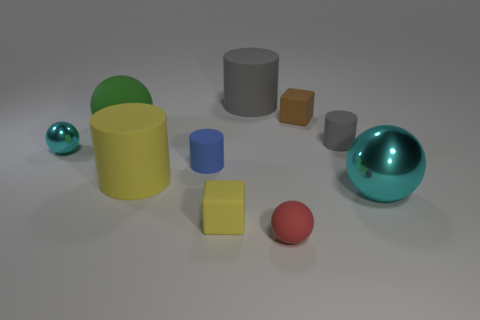Are there an equal number of green balls in front of the tiny blue object and red matte objects?
Provide a succinct answer. No. Do the blue matte cylinder and the green rubber object have the same size?
Your response must be concise. No. How many rubber objects are either tiny cyan objects or green cylinders?
Give a very brief answer. 0. There is a brown object that is the same size as the red thing; what material is it?
Give a very brief answer. Rubber. What number of other objects are the same material as the red thing?
Your answer should be very brief. 7. Is the number of small cyan shiny balls in front of the small rubber sphere less than the number of blue matte blocks?
Provide a succinct answer. No. Do the small yellow object and the big yellow object have the same shape?
Your answer should be very brief. No. What size is the cube that is on the left side of the small ball on the right side of the cube in front of the tiny gray rubber object?
Provide a short and direct response. Small. What is the material of the other large object that is the same shape as the big green rubber thing?
Your answer should be compact. Metal. Are there any other things that have the same size as the blue matte cylinder?
Provide a short and direct response. Yes. 